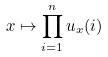Convert formula to latex. <formula><loc_0><loc_0><loc_500><loc_500>x \mapsto \prod _ { i = 1 } ^ { n } u _ { x } ( i )</formula> 